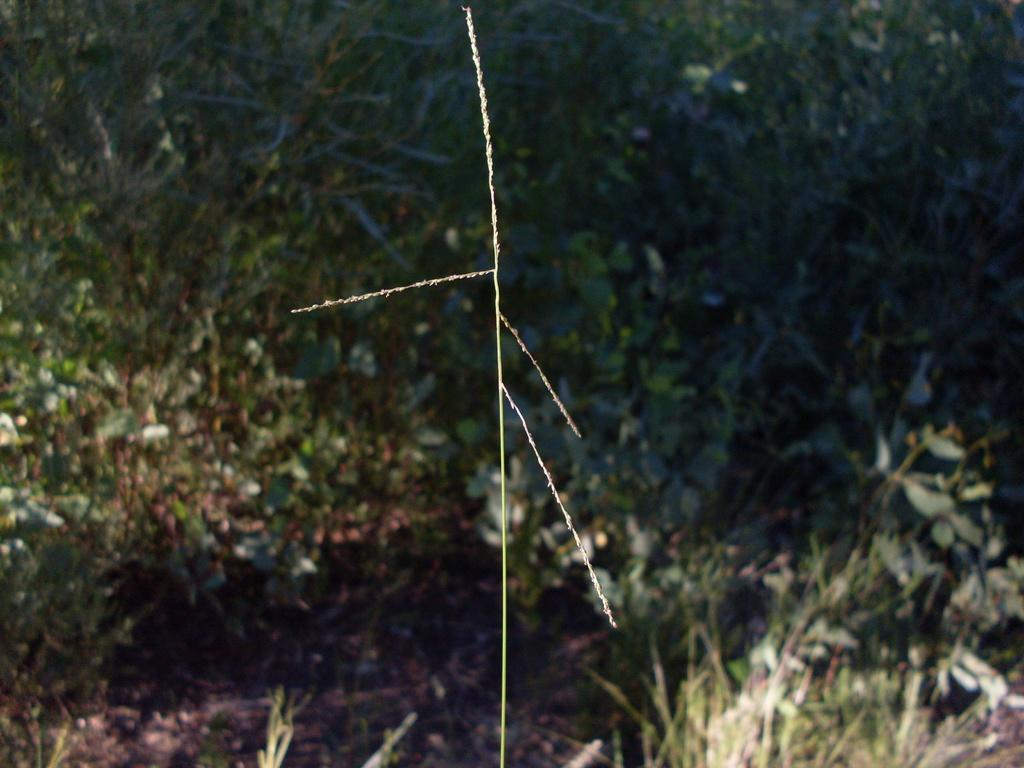What type of vegetation can be seen in the image? There are plants in the image. What is covering the ground in the image? There is grass on the ground in the image. Where is the cork located in the image? There is no cork present in the image. What type of hook can be seen in the image? There is no hook present in the image. 